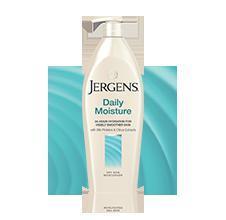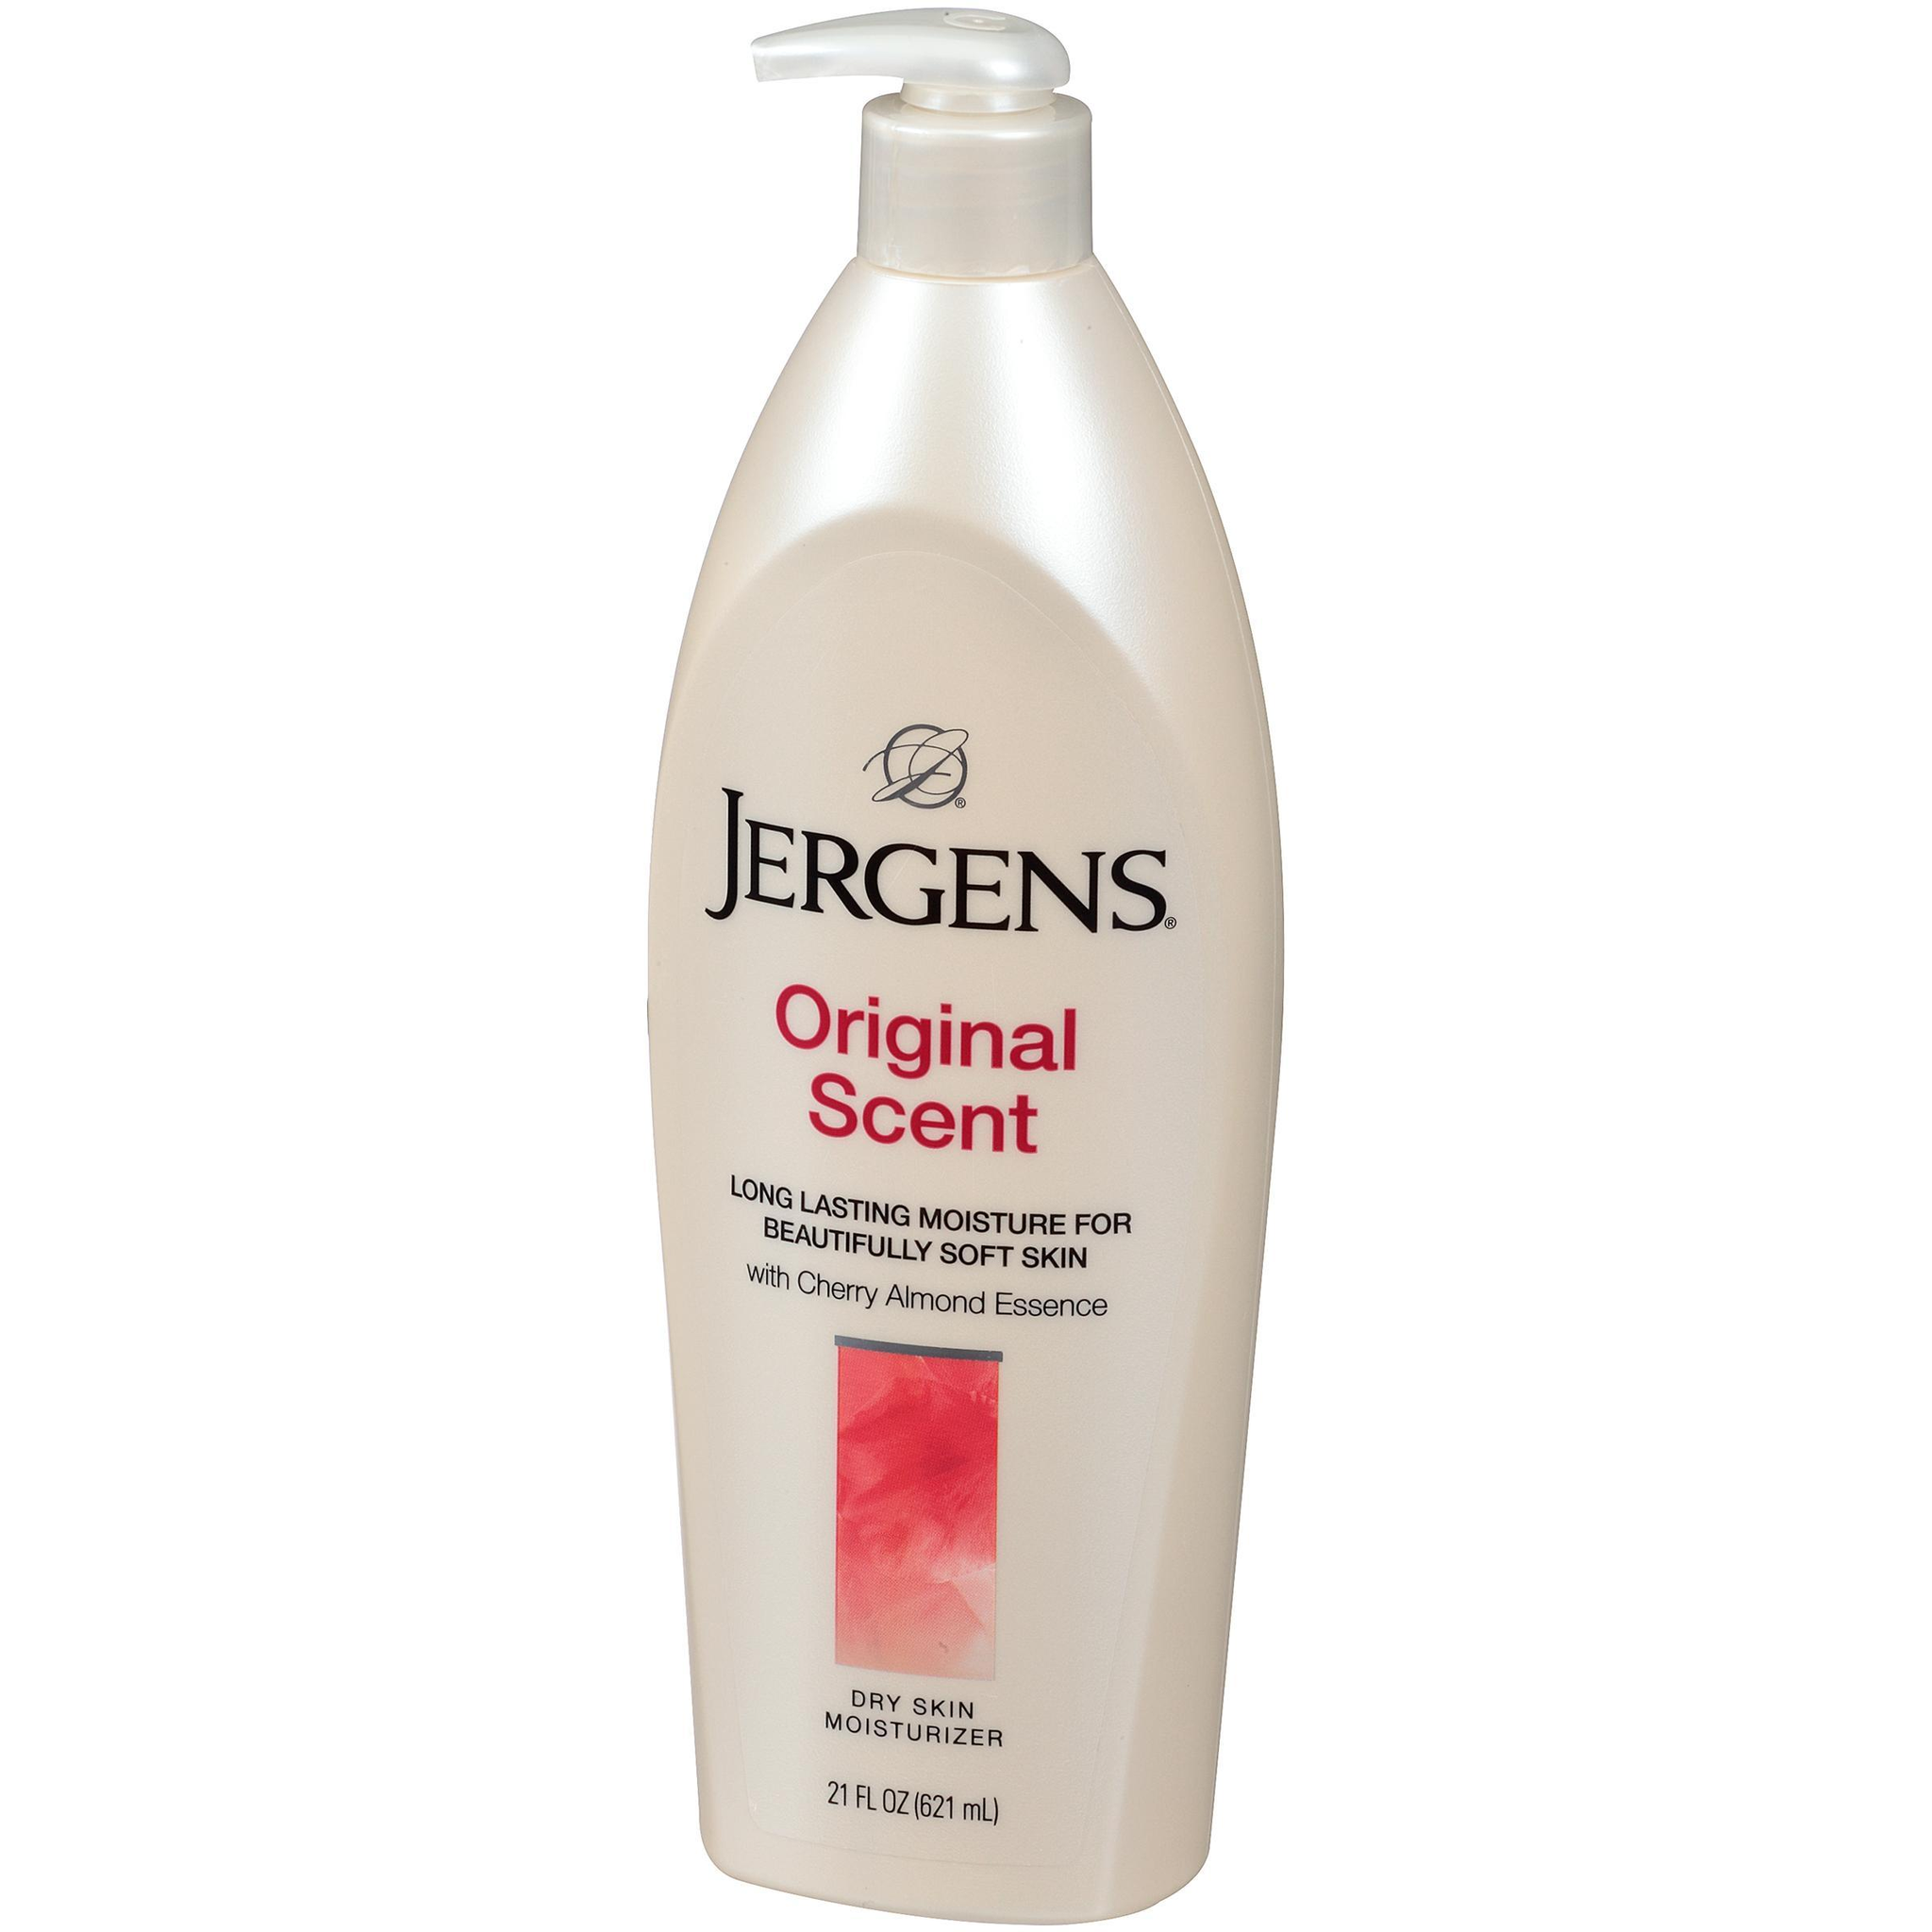The first image is the image on the left, the second image is the image on the right. Examine the images to the left and right. Is the description "The bottle in the image on the right is turned at a slight angle." accurate? Answer yes or no. Yes. 